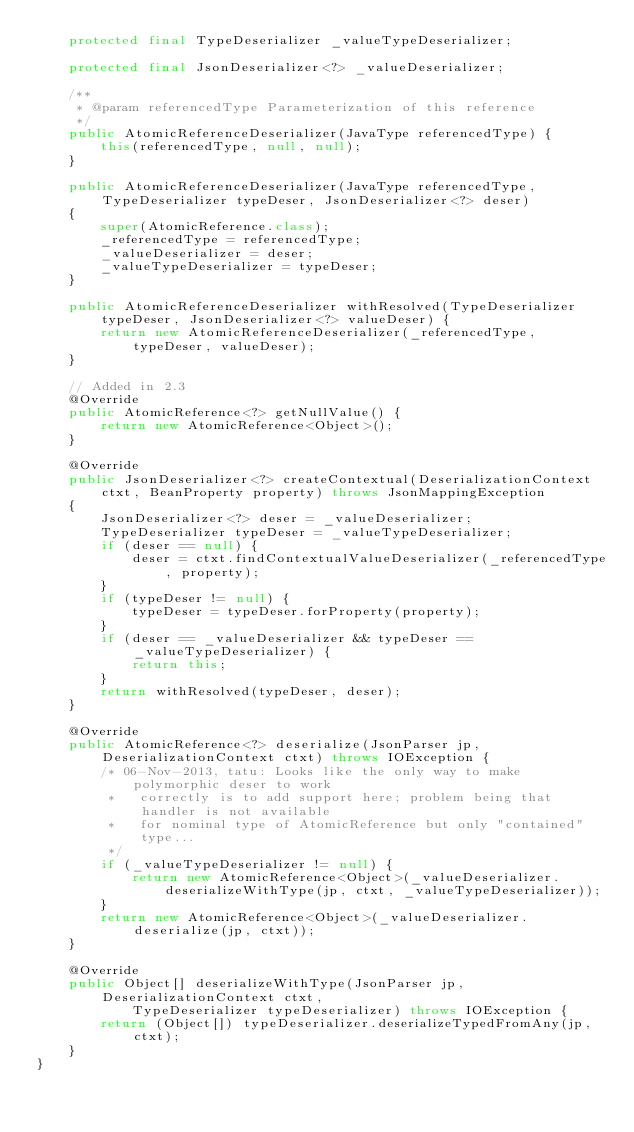Convert code to text. <code><loc_0><loc_0><loc_500><loc_500><_Java_>    protected final TypeDeserializer _valueTypeDeserializer;

    protected final JsonDeserializer<?> _valueDeserializer;
    
    /**
     * @param referencedType Parameterization of this reference
     */
    public AtomicReferenceDeserializer(JavaType referencedType) {
        this(referencedType, null, null);
    }
    
    public AtomicReferenceDeserializer(JavaType referencedType, TypeDeserializer typeDeser, JsonDeserializer<?> deser)
    {
        super(AtomicReference.class);
        _referencedType = referencedType;
        _valueDeserializer = deser;
        _valueTypeDeserializer = typeDeser;
    }

    public AtomicReferenceDeserializer withResolved(TypeDeserializer typeDeser, JsonDeserializer<?> valueDeser) {
        return new AtomicReferenceDeserializer(_referencedType, typeDeser, valueDeser);
    }
    
    // Added in 2.3
    @Override
    public AtomicReference<?> getNullValue() {
        return new AtomicReference<Object>();
    }

    @Override
    public JsonDeserializer<?> createContextual(DeserializationContext ctxt, BeanProperty property) throws JsonMappingException
    {
        JsonDeserializer<?> deser = _valueDeserializer;
        TypeDeserializer typeDeser = _valueTypeDeserializer;
        if (deser == null) {
            deser = ctxt.findContextualValueDeserializer(_referencedType, property);
        }
        if (typeDeser != null) {
            typeDeser = typeDeser.forProperty(property);
        }
        if (deser == _valueDeserializer && typeDeser == _valueTypeDeserializer) {
            return this;
        }
        return withResolved(typeDeser, deser);
    }

    @Override
    public AtomicReference<?> deserialize(JsonParser jp, DeserializationContext ctxt) throws IOException {
        /* 06-Nov-2013, tatu: Looks like the only way to make polymorphic deser to work
         *   correctly is to add support here; problem being that handler is not available
         *   for nominal type of AtomicReference but only "contained" type...
         */
        if (_valueTypeDeserializer != null) {
            return new AtomicReference<Object>(_valueDeserializer.deserializeWithType(jp, ctxt, _valueTypeDeserializer));
        }
        return new AtomicReference<Object>(_valueDeserializer.deserialize(jp, ctxt));
    }

    @Override
    public Object[] deserializeWithType(JsonParser jp, DeserializationContext ctxt,
            TypeDeserializer typeDeserializer) throws IOException {
        return (Object[]) typeDeserializer.deserializeTypedFromAny(jp, ctxt);
    }
}
</code> 